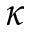Convert formula to latex. <formula><loc_0><loc_0><loc_500><loc_500>\kappa</formula> 